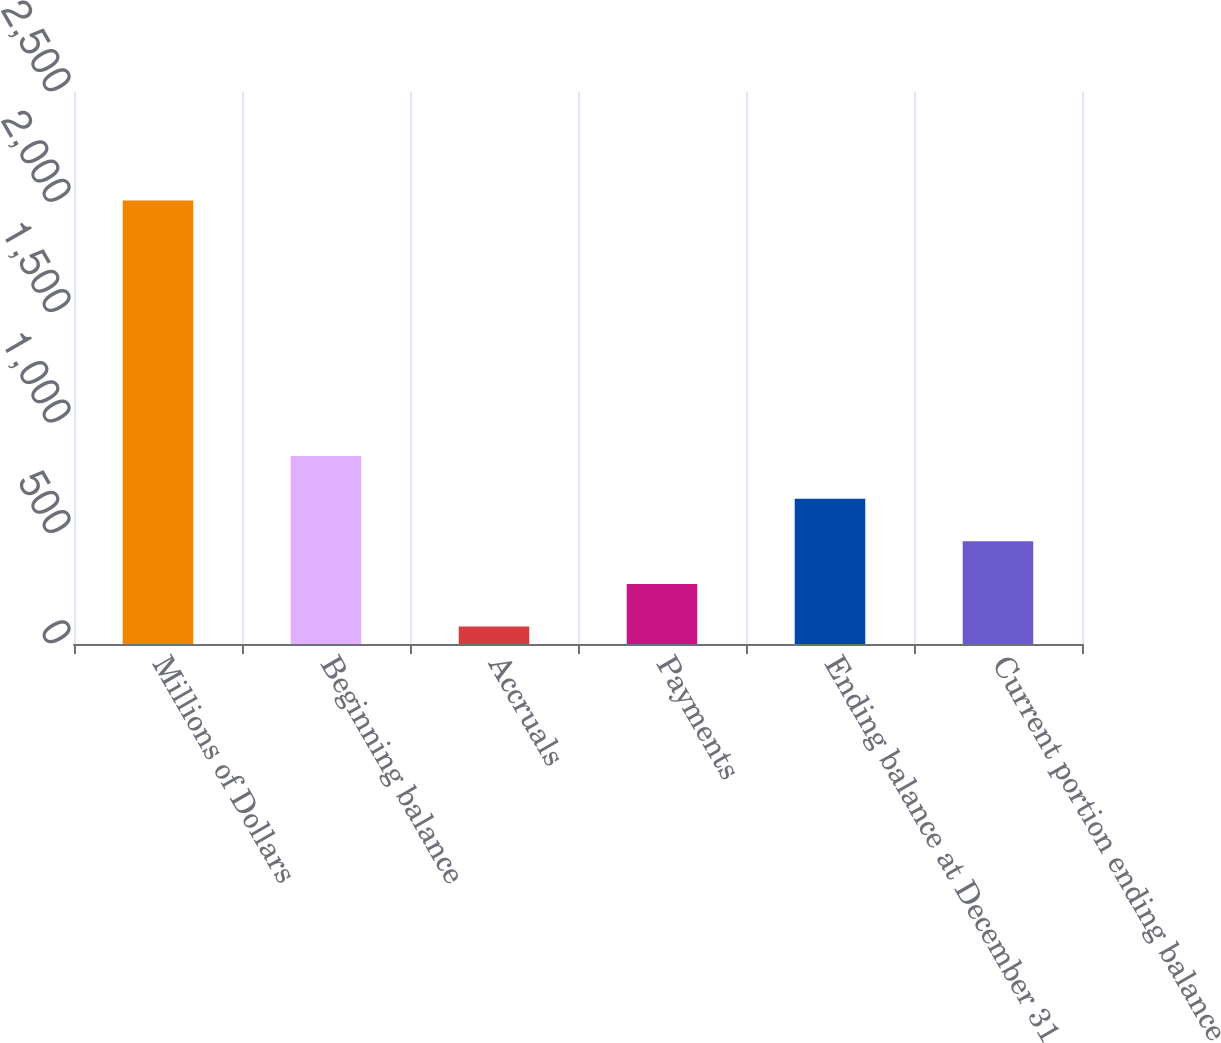Convert chart to OTSL. <chart><loc_0><loc_0><loc_500><loc_500><bar_chart><fcel>Millions of Dollars<fcel>Beginning balance<fcel>Accruals<fcel>Payments<fcel>Ending balance at December 31<fcel>Current portion ending balance<nl><fcel>2009<fcel>851<fcel>79<fcel>272<fcel>658<fcel>465<nl></chart> 